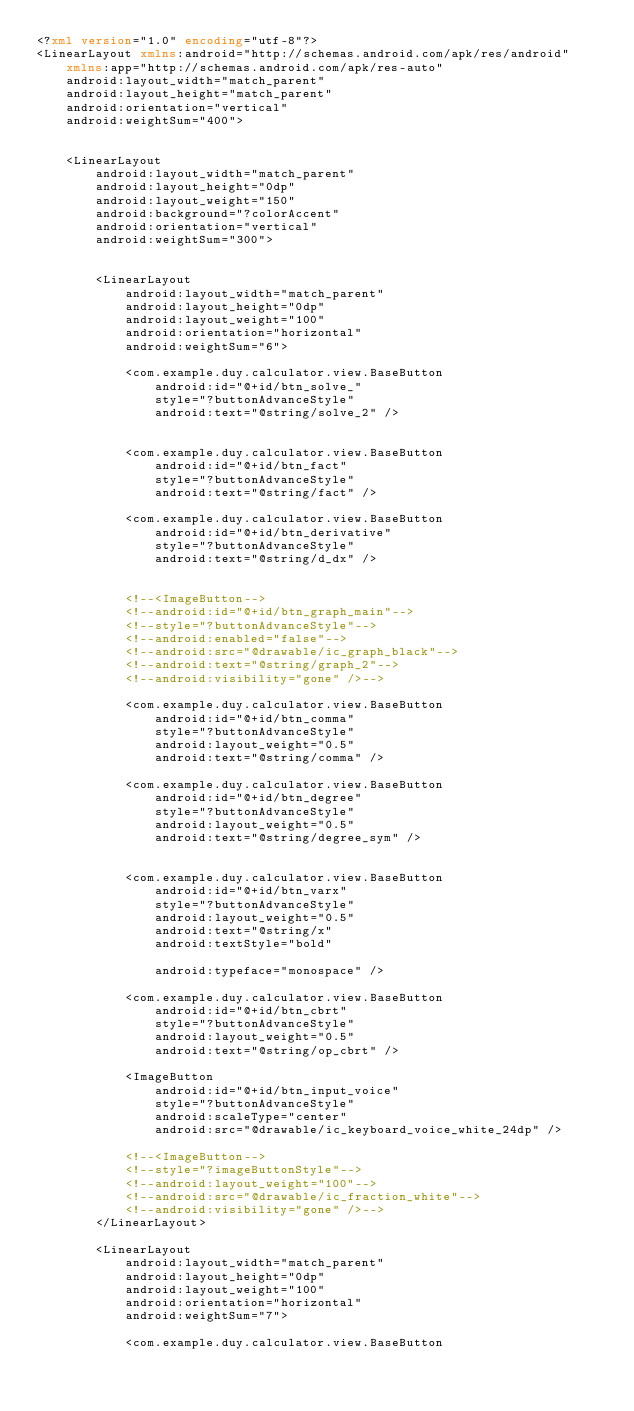<code> <loc_0><loc_0><loc_500><loc_500><_XML_><?xml version="1.0" encoding="utf-8"?>
<LinearLayout xmlns:android="http://schemas.android.com/apk/res/android"
    xmlns:app="http://schemas.android.com/apk/res-auto"
    android:layout_width="match_parent"
    android:layout_height="match_parent"
    android:orientation="vertical"
    android:weightSum="400">


    <LinearLayout
        android:layout_width="match_parent"
        android:layout_height="0dp"
        android:layout_weight="150"
        android:background="?colorAccent"
        android:orientation="vertical"
        android:weightSum="300">


        <LinearLayout
            android:layout_width="match_parent"
            android:layout_height="0dp"
            android:layout_weight="100"
            android:orientation="horizontal"
            android:weightSum="6">

            <com.example.duy.calculator.view.BaseButton
                android:id="@+id/btn_solve_"
                style="?buttonAdvanceStyle"
                android:text="@string/solve_2" />


            <com.example.duy.calculator.view.BaseButton
                android:id="@+id/btn_fact"
                style="?buttonAdvanceStyle"
                android:text="@string/fact" />

            <com.example.duy.calculator.view.BaseButton
                android:id="@+id/btn_derivative"
                style="?buttonAdvanceStyle"
                android:text="@string/d_dx" />


            <!--<ImageButton-->
            <!--android:id="@+id/btn_graph_main"-->
            <!--style="?buttonAdvanceStyle"-->
            <!--android:enabled="false"-->
            <!--android:src="@drawable/ic_graph_black"-->
            <!--android:text="@string/graph_2"-->
            <!--android:visibility="gone" />-->

            <com.example.duy.calculator.view.BaseButton
                android:id="@+id/btn_comma"
                style="?buttonAdvanceStyle"
                android:layout_weight="0.5"
                android:text="@string/comma" />

            <com.example.duy.calculator.view.BaseButton
                android:id="@+id/btn_degree"
                style="?buttonAdvanceStyle"
                android:layout_weight="0.5"
                android:text="@string/degree_sym" />


            <com.example.duy.calculator.view.BaseButton
                android:id="@+id/btn_varx"
                style="?buttonAdvanceStyle"
                android:layout_weight="0.5"
                android:text="@string/x"
                android:textStyle="bold"

                android:typeface="monospace" />

            <com.example.duy.calculator.view.BaseButton
                android:id="@+id/btn_cbrt"
                style="?buttonAdvanceStyle"
                android:layout_weight="0.5"
                android:text="@string/op_cbrt" />

            <ImageButton
                android:id="@+id/btn_input_voice"
                style="?buttonAdvanceStyle"
                android:scaleType="center"
                android:src="@drawable/ic_keyboard_voice_white_24dp" />

            <!--<ImageButton-->
            <!--style="?imageButtonStyle"-->
            <!--android:layout_weight="100"-->
            <!--android:src="@drawable/ic_fraction_white"-->
            <!--android:visibility="gone" />-->
        </LinearLayout>

        <LinearLayout
            android:layout_width="match_parent"
            android:layout_height="0dp"
            android:layout_weight="100"
            android:orientation="horizontal"
            android:weightSum="7">

            <com.example.duy.calculator.view.BaseButton</code> 